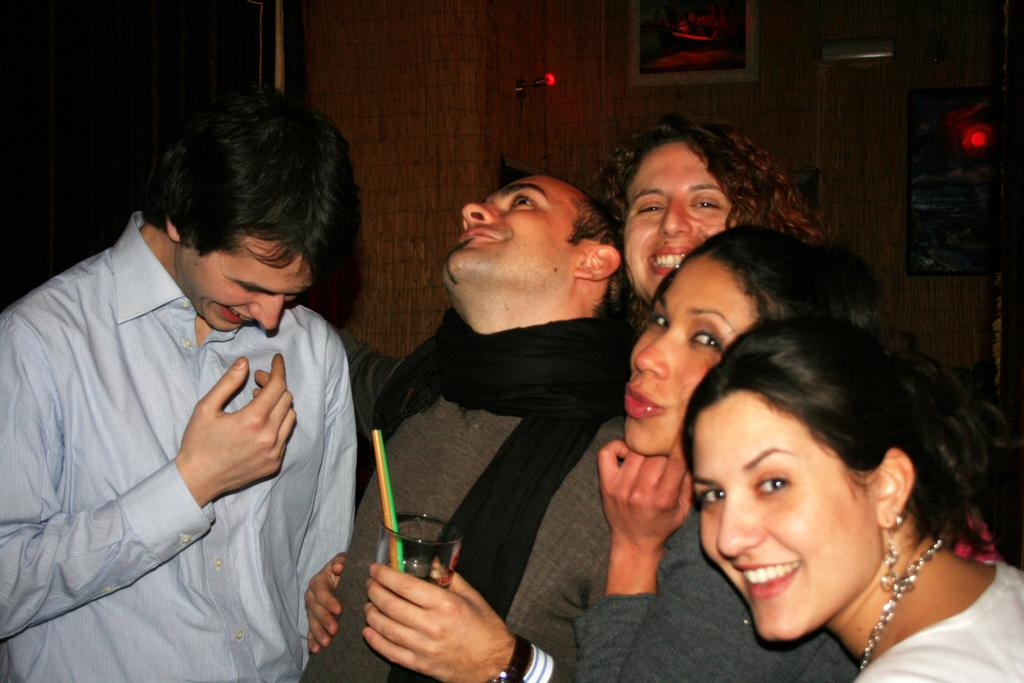How many people are in the group shown in the image? There is a group of people in the image. What are the people in the group doing? The people are standing over a place, and one person in the middle is holding a glass of wine. What is the general mood of the people in the image? All the people in the group are smiling. How many sheep can be seen grazing in the background of the image? There are no sheep present in the image. What type of crime is being committed in the image? There is no crime being committed in the image; it shows a group of people standing and smiling. 